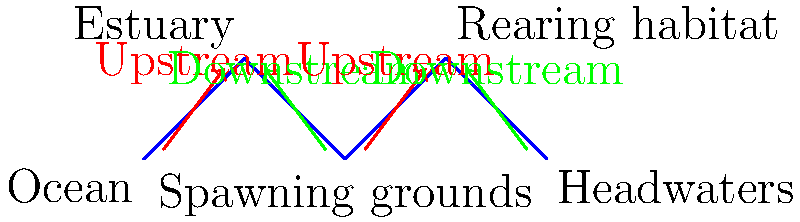Based on the diagram, which section of the river system serves as the primary spawning area for anadromous fish species, and how does this relate to their overall migration pattern? To answer this question, let's analyze the diagram step-by-step:

1. The river system is divided into five main sections: Ocean, Estuary, Spawning grounds, Rearing habitat, and Headwaters.

2. The red arrows indicate upstream migration, while the green arrows show downstream migration.

3. We can see that the fish are migrating upstream from the ocean through the estuary.

4. The section labeled "Spawning grounds" is located in the middle of the river system.

5. After the spawning grounds, we see both upstream and downstream migrations, indicating that some fish continue upstream while others (likely juveniles) begin their journey back to the ocean.

6. The spawning grounds are strategically located between the estuary and the rearing habitat, allowing adult fish to reach them for reproduction and providing access to suitable habitats for juvenile fish development.

7. This migration pattern is typical for anadromous fish species, which are born in freshwater, migrate to the ocean to mature, and then return to freshwater to spawn.

The primary spawning area for anadromous fish species in this river system is the section labeled "Spawning grounds." This location is crucial in the overall migration pattern as it represents the destination for adult fish migrating upstream from the ocean and the starting point for the next generation's journey downstream.
Answer: Spawning grounds; central to upstream adult migration and downstream juvenile migration 